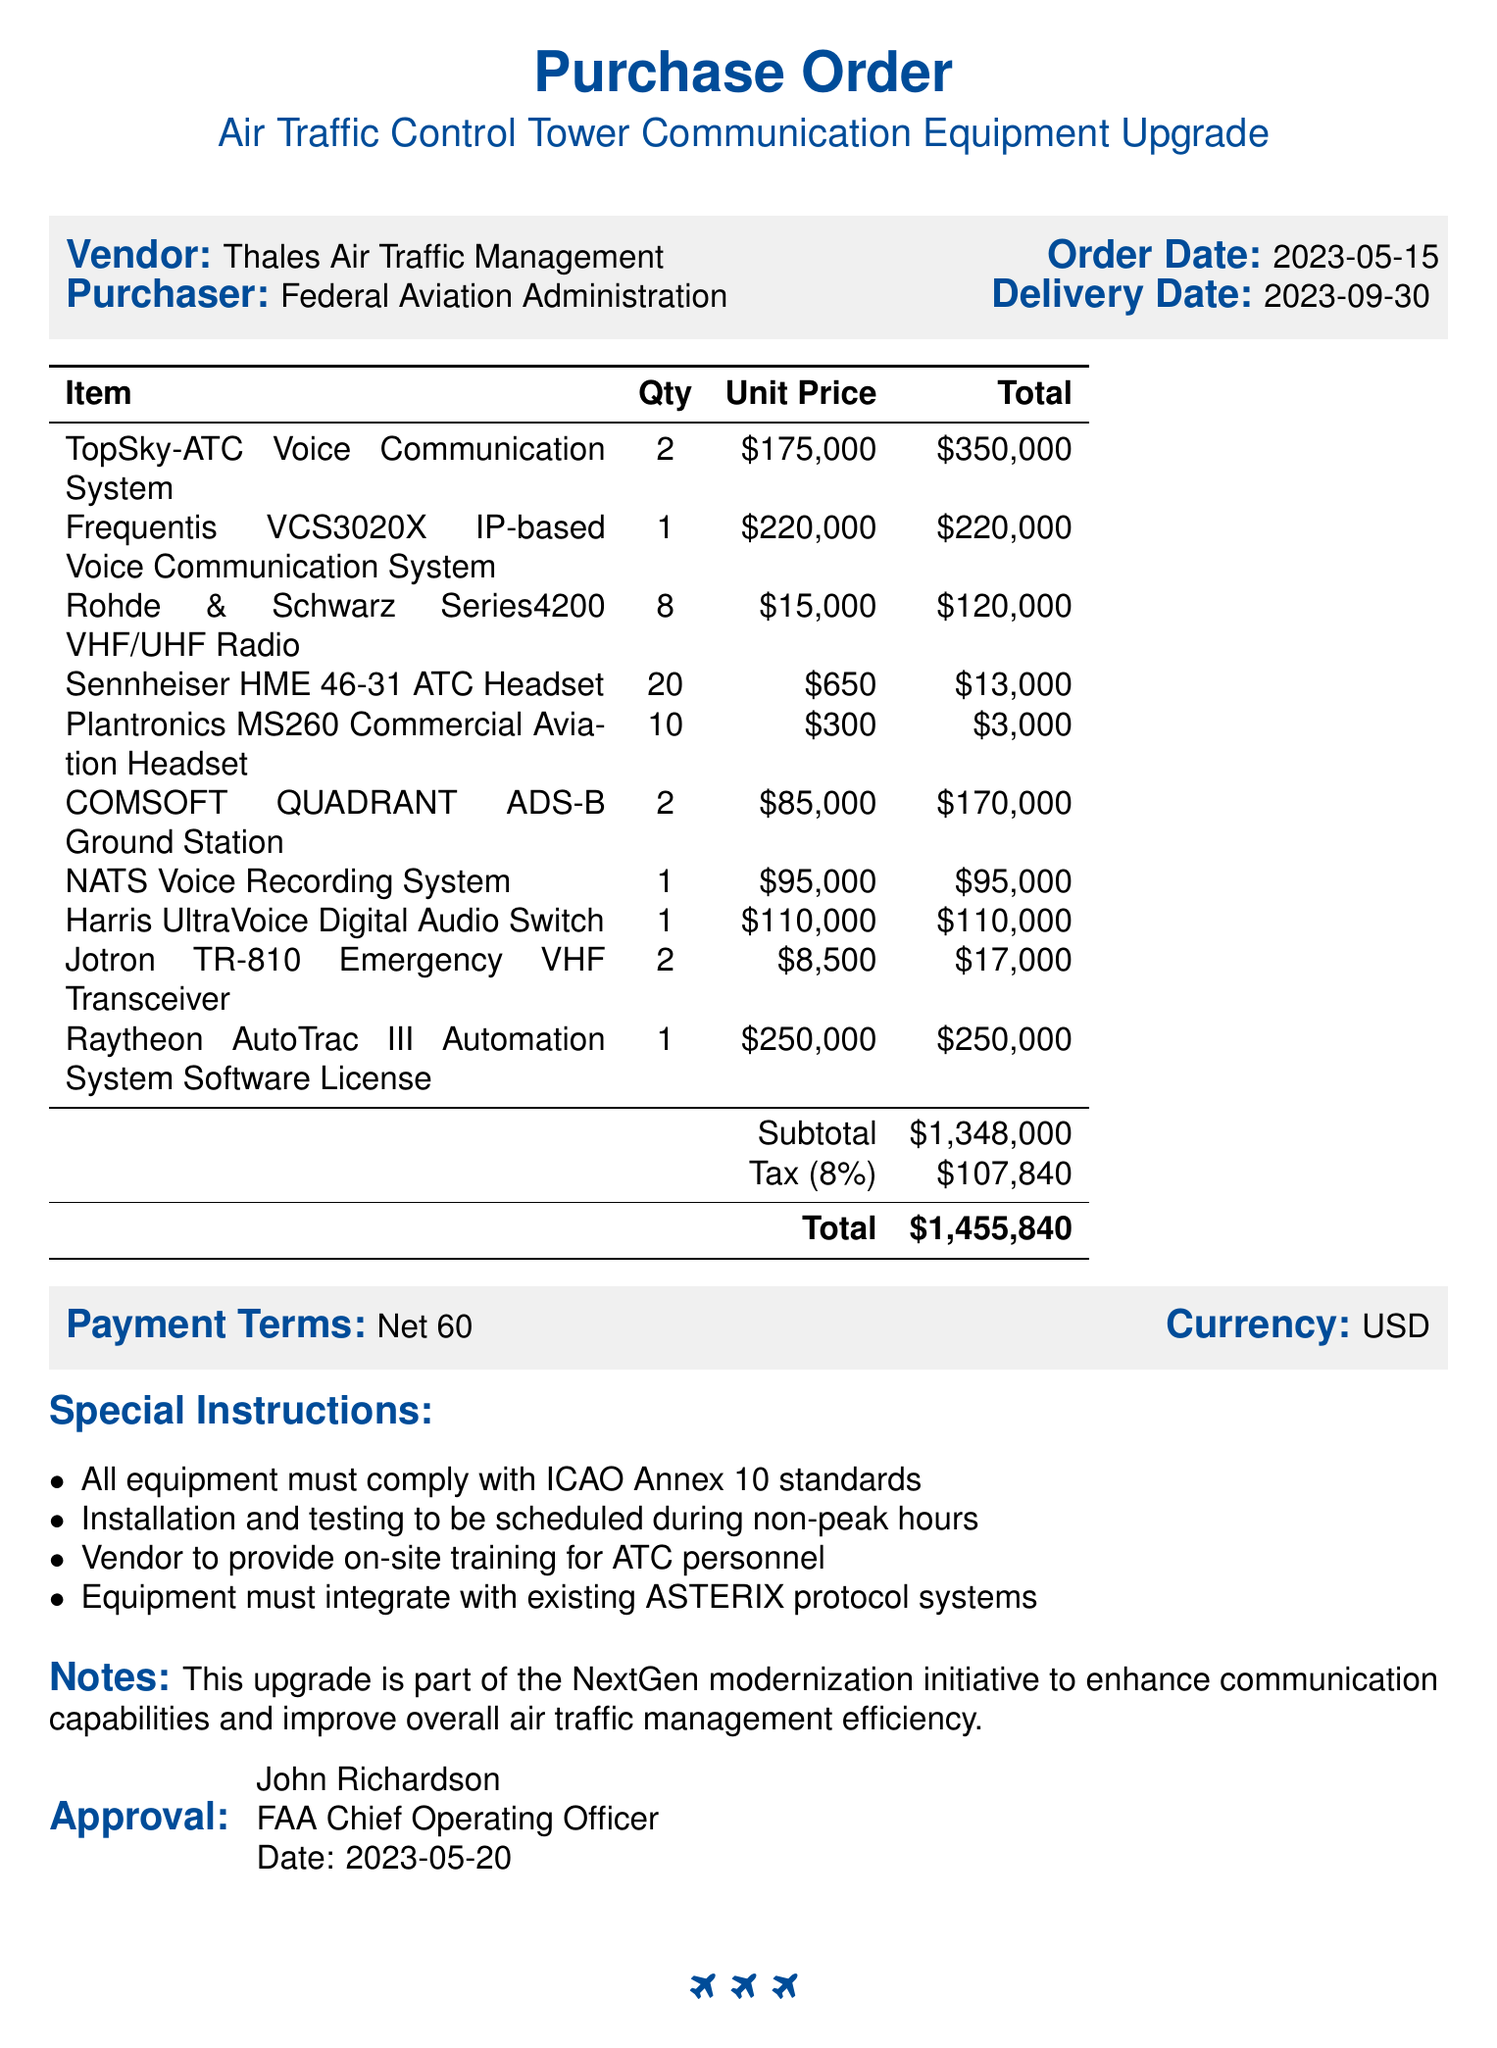What is the vendor name? The vendor for the purchase order is listed as Thales Air Traffic Management.
Answer: Thales Air Traffic Management What is the order date? The order date is specifically mentioned in the document as May 15, 2023.
Answer: 2023-05-15 How many units of the TopSky-ATC Voice Communication System were ordered? The quantity of TopSky-ATC Voice Communication Systems is stated as 2 in the items list.
Answer: 2 What is the total amount for the purchase order? The total amount, including all items and tax, is provided as $1,455,840 in the summary section.
Answer: $1,455,840 Who is the approver of this purchase order? The approver's name is mentioned as John Richardson, who is the FAA Chief Operating Officer.
Answer: John Richardson What is the tax rate applied to the subtotal? The document specifies an 8% tax rate applied to the subtotal of the purchase.
Answer: 8% What special instruction mentions ICAO standards? The special instruction states "All equipment must comply with ICAO Annex 10 standards."
Answer: All equipment must comply with ICAO Annex 10 standards How many Sennheiser HME 46-31 ATC Headsets were ordered? The document states that 20 units of the Sennheiser HME 46-31 ATC Headsets were ordered.
Answer: 20 What is the delivery date for this order? The delivery date is clearly stated as September 30, 2023, in the document.
Answer: 2023-09-30 